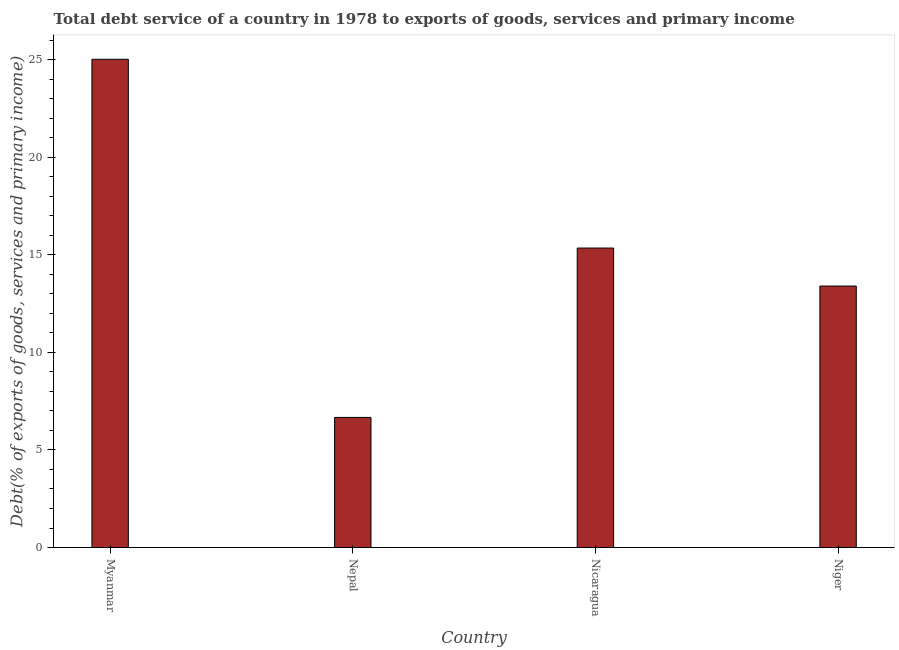Does the graph contain any zero values?
Ensure brevity in your answer.  No. What is the title of the graph?
Your response must be concise. Total debt service of a country in 1978 to exports of goods, services and primary income. What is the label or title of the X-axis?
Your response must be concise. Country. What is the label or title of the Y-axis?
Provide a succinct answer. Debt(% of exports of goods, services and primary income). What is the total debt service in Nicaragua?
Ensure brevity in your answer.  15.34. Across all countries, what is the maximum total debt service?
Give a very brief answer. 25.02. Across all countries, what is the minimum total debt service?
Your response must be concise. 6.67. In which country was the total debt service maximum?
Your response must be concise. Myanmar. In which country was the total debt service minimum?
Your response must be concise. Nepal. What is the sum of the total debt service?
Keep it short and to the point. 60.43. What is the difference between the total debt service in Nicaragua and Niger?
Give a very brief answer. 1.95. What is the average total debt service per country?
Offer a terse response. 15.11. What is the median total debt service?
Offer a very short reply. 14.37. What is the ratio of the total debt service in Myanmar to that in Niger?
Give a very brief answer. 1.87. What is the difference between the highest and the second highest total debt service?
Ensure brevity in your answer.  9.67. What is the difference between the highest and the lowest total debt service?
Keep it short and to the point. 18.35. In how many countries, is the total debt service greater than the average total debt service taken over all countries?
Your answer should be compact. 2. What is the difference between two consecutive major ticks on the Y-axis?
Your response must be concise. 5. Are the values on the major ticks of Y-axis written in scientific E-notation?
Give a very brief answer. No. What is the Debt(% of exports of goods, services and primary income) in Myanmar?
Ensure brevity in your answer.  25.02. What is the Debt(% of exports of goods, services and primary income) in Nepal?
Ensure brevity in your answer.  6.67. What is the Debt(% of exports of goods, services and primary income) in Nicaragua?
Provide a short and direct response. 15.34. What is the Debt(% of exports of goods, services and primary income) in Niger?
Keep it short and to the point. 13.4. What is the difference between the Debt(% of exports of goods, services and primary income) in Myanmar and Nepal?
Ensure brevity in your answer.  18.35. What is the difference between the Debt(% of exports of goods, services and primary income) in Myanmar and Nicaragua?
Provide a succinct answer. 9.67. What is the difference between the Debt(% of exports of goods, services and primary income) in Myanmar and Niger?
Your response must be concise. 11.62. What is the difference between the Debt(% of exports of goods, services and primary income) in Nepal and Nicaragua?
Offer a terse response. -8.68. What is the difference between the Debt(% of exports of goods, services and primary income) in Nepal and Niger?
Offer a terse response. -6.73. What is the difference between the Debt(% of exports of goods, services and primary income) in Nicaragua and Niger?
Provide a succinct answer. 1.95. What is the ratio of the Debt(% of exports of goods, services and primary income) in Myanmar to that in Nepal?
Your answer should be compact. 3.75. What is the ratio of the Debt(% of exports of goods, services and primary income) in Myanmar to that in Nicaragua?
Provide a succinct answer. 1.63. What is the ratio of the Debt(% of exports of goods, services and primary income) in Myanmar to that in Niger?
Your answer should be very brief. 1.87. What is the ratio of the Debt(% of exports of goods, services and primary income) in Nepal to that in Nicaragua?
Your response must be concise. 0.43. What is the ratio of the Debt(% of exports of goods, services and primary income) in Nepal to that in Niger?
Ensure brevity in your answer.  0.5. What is the ratio of the Debt(% of exports of goods, services and primary income) in Nicaragua to that in Niger?
Provide a short and direct response. 1.15. 